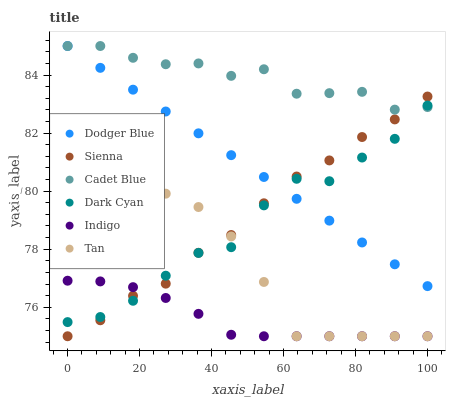Does Indigo have the minimum area under the curve?
Answer yes or no. Yes. Does Cadet Blue have the maximum area under the curve?
Answer yes or no. Yes. Does Sienna have the minimum area under the curve?
Answer yes or no. No. Does Sienna have the maximum area under the curve?
Answer yes or no. No. Is Dodger Blue the smoothest?
Answer yes or no. Yes. Is Dark Cyan the roughest?
Answer yes or no. Yes. Is Indigo the smoothest?
Answer yes or no. No. Is Indigo the roughest?
Answer yes or no. No. Does Indigo have the lowest value?
Answer yes or no. Yes. Does Dodger Blue have the lowest value?
Answer yes or no. No. Does Dodger Blue have the highest value?
Answer yes or no. Yes. Does Sienna have the highest value?
Answer yes or no. No. Is Indigo less than Cadet Blue?
Answer yes or no. Yes. Is Dodger Blue greater than Indigo?
Answer yes or no. Yes. Does Indigo intersect Dark Cyan?
Answer yes or no. Yes. Is Indigo less than Dark Cyan?
Answer yes or no. No. Is Indigo greater than Dark Cyan?
Answer yes or no. No. Does Indigo intersect Cadet Blue?
Answer yes or no. No. 